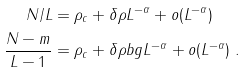Convert formula to latex. <formula><loc_0><loc_0><loc_500><loc_500>N / L & = \rho _ { c } + \delta \rho L ^ { - \alpha } + o ( L ^ { - \alpha } ) \\ \frac { N - m } { L - 1 } & = \rho _ { c } + \delta \rho b g L ^ { - \alpha } + o ( L ^ { - \alpha } ) \ . \\</formula> 